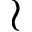<formula> <loc_0><loc_0><loc_500><loc_500>\wr</formula> 